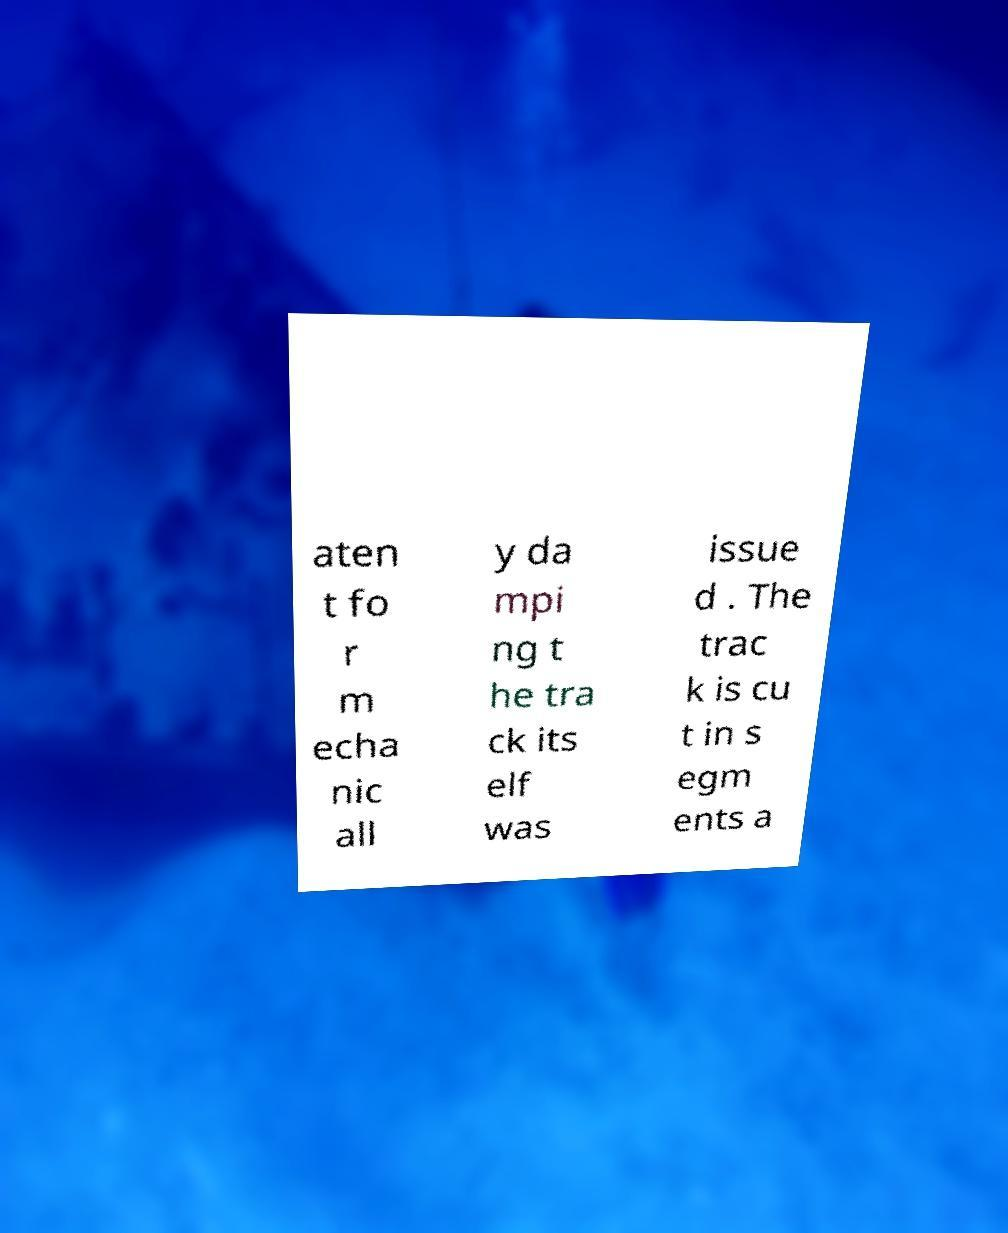There's text embedded in this image that I need extracted. Can you transcribe it verbatim? aten t fo r m echa nic all y da mpi ng t he tra ck its elf was issue d . The trac k is cu t in s egm ents a 